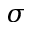<formula> <loc_0><loc_0><loc_500><loc_500>\sigma</formula> 